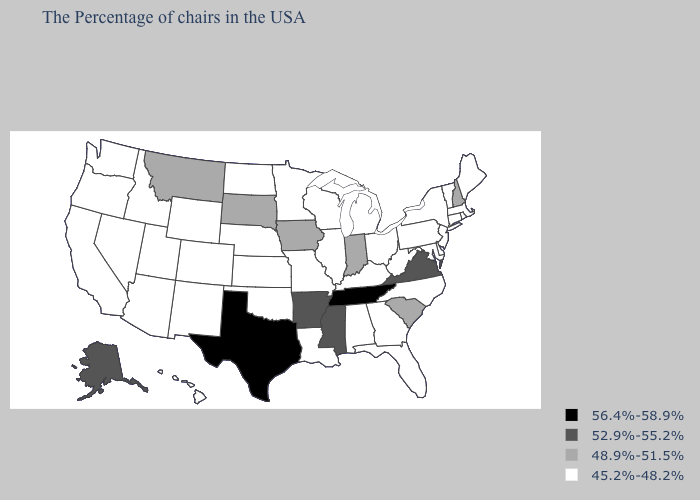Among the states that border Massachusetts , which have the lowest value?
Short answer required. Rhode Island, Vermont, Connecticut, New York. Name the states that have a value in the range 56.4%-58.9%?
Give a very brief answer. Tennessee, Texas. Among the states that border Illinois , which have the highest value?
Be succinct. Indiana, Iowa. Name the states that have a value in the range 52.9%-55.2%?
Short answer required. Virginia, Mississippi, Arkansas, Alaska. Which states have the lowest value in the Northeast?
Short answer required. Maine, Massachusetts, Rhode Island, Vermont, Connecticut, New York, New Jersey, Pennsylvania. How many symbols are there in the legend?
Quick response, please. 4. Name the states that have a value in the range 56.4%-58.9%?
Answer briefly. Tennessee, Texas. Does the first symbol in the legend represent the smallest category?
Short answer required. No. Which states have the highest value in the USA?
Keep it brief. Tennessee, Texas. Among the states that border Maryland , does Virginia have the highest value?
Write a very short answer. Yes. Name the states that have a value in the range 56.4%-58.9%?
Give a very brief answer. Tennessee, Texas. How many symbols are there in the legend?
Concise answer only. 4. What is the value of Idaho?
Write a very short answer. 45.2%-48.2%. Name the states that have a value in the range 52.9%-55.2%?
Give a very brief answer. Virginia, Mississippi, Arkansas, Alaska. 